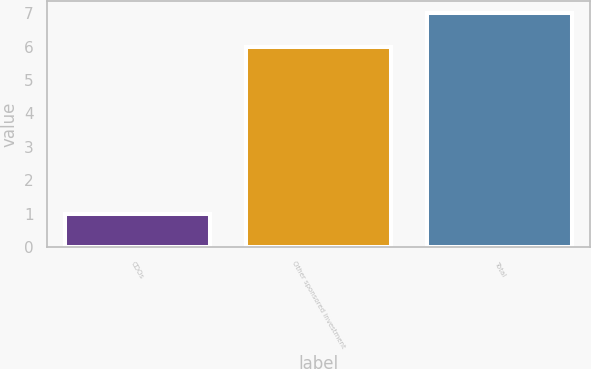<chart> <loc_0><loc_0><loc_500><loc_500><bar_chart><fcel>CDOs<fcel>Other sponsored investment<fcel>Total<nl><fcel>1<fcel>6<fcel>7<nl></chart> 